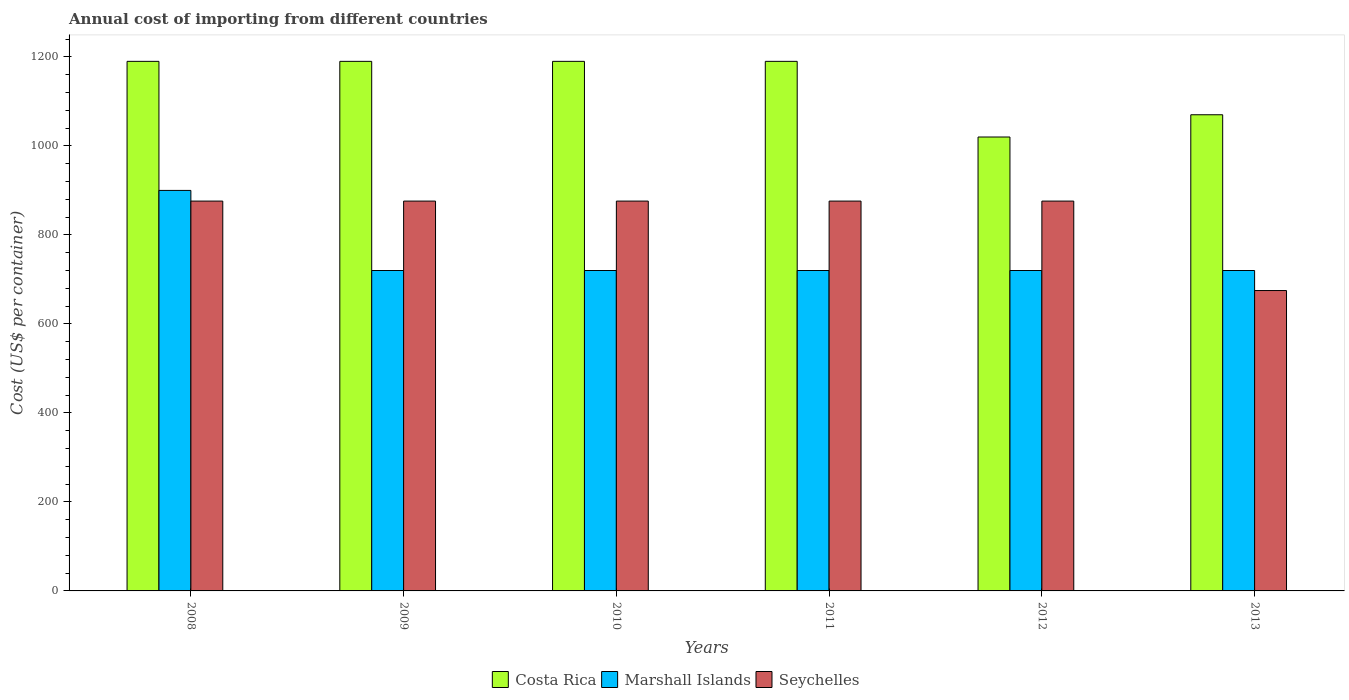How many bars are there on the 6th tick from the left?
Provide a short and direct response. 3. What is the total annual cost of importing in Seychelles in 2013?
Ensure brevity in your answer.  675. Across all years, what is the maximum total annual cost of importing in Marshall Islands?
Your response must be concise. 900. Across all years, what is the minimum total annual cost of importing in Costa Rica?
Provide a short and direct response. 1020. In which year was the total annual cost of importing in Costa Rica maximum?
Your response must be concise. 2008. In which year was the total annual cost of importing in Seychelles minimum?
Ensure brevity in your answer.  2013. What is the total total annual cost of importing in Marshall Islands in the graph?
Provide a short and direct response. 4500. What is the difference between the total annual cost of importing in Seychelles in 2008 and that in 2011?
Offer a very short reply. 0. What is the difference between the total annual cost of importing in Seychelles in 2009 and the total annual cost of importing in Marshall Islands in 2013?
Keep it short and to the point. 156. What is the average total annual cost of importing in Seychelles per year?
Your answer should be very brief. 842.5. In the year 2008, what is the difference between the total annual cost of importing in Seychelles and total annual cost of importing in Marshall Islands?
Keep it short and to the point. -24. What is the ratio of the total annual cost of importing in Seychelles in 2009 to that in 2011?
Make the answer very short. 1. What is the difference between the highest and the second highest total annual cost of importing in Seychelles?
Offer a very short reply. 0. What is the difference between the highest and the lowest total annual cost of importing in Marshall Islands?
Ensure brevity in your answer.  180. In how many years, is the total annual cost of importing in Seychelles greater than the average total annual cost of importing in Seychelles taken over all years?
Keep it short and to the point. 5. What does the 1st bar from the left in 2011 represents?
Provide a succinct answer. Costa Rica. What does the 3rd bar from the right in 2008 represents?
Give a very brief answer. Costa Rica. How many bars are there?
Your response must be concise. 18. What is the difference between two consecutive major ticks on the Y-axis?
Your answer should be compact. 200. Does the graph contain any zero values?
Provide a short and direct response. No. Does the graph contain grids?
Give a very brief answer. No. How are the legend labels stacked?
Provide a succinct answer. Horizontal. What is the title of the graph?
Provide a short and direct response. Annual cost of importing from different countries. Does "Singapore" appear as one of the legend labels in the graph?
Your response must be concise. No. What is the label or title of the Y-axis?
Offer a terse response. Cost (US$ per container). What is the Cost (US$ per container) in Costa Rica in 2008?
Keep it short and to the point. 1190. What is the Cost (US$ per container) of Marshall Islands in 2008?
Make the answer very short. 900. What is the Cost (US$ per container) of Seychelles in 2008?
Your answer should be compact. 876. What is the Cost (US$ per container) of Costa Rica in 2009?
Offer a very short reply. 1190. What is the Cost (US$ per container) of Marshall Islands in 2009?
Your response must be concise. 720. What is the Cost (US$ per container) in Seychelles in 2009?
Keep it short and to the point. 876. What is the Cost (US$ per container) of Costa Rica in 2010?
Make the answer very short. 1190. What is the Cost (US$ per container) of Marshall Islands in 2010?
Provide a short and direct response. 720. What is the Cost (US$ per container) of Seychelles in 2010?
Provide a short and direct response. 876. What is the Cost (US$ per container) of Costa Rica in 2011?
Keep it short and to the point. 1190. What is the Cost (US$ per container) in Marshall Islands in 2011?
Make the answer very short. 720. What is the Cost (US$ per container) in Seychelles in 2011?
Ensure brevity in your answer.  876. What is the Cost (US$ per container) in Costa Rica in 2012?
Ensure brevity in your answer.  1020. What is the Cost (US$ per container) of Marshall Islands in 2012?
Provide a succinct answer. 720. What is the Cost (US$ per container) in Seychelles in 2012?
Give a very brief answer. 876. What is the Cost (US$ per container) of Costa Rica in 2013?
Provide a short and direct response. 1070. What is the Cost (US$ per container) of Marshall Islands in 2013?
Ensure brevity in your answer.  720. What is the Cost (US$ per container) of Seychelles in 2013?
Offer a terse response. 675. Across all years, what is the maximum Cost (US$ per container) of Costa Rica?
Keep it short and to the point. 1190. Across all years, what is the maximum Cost (US$ per container) of Marshall Islands?
Offer a very short reply. 900. Across all years, what is the maximum Cost (US$ per container) of Seychelles?
Make the answer very short. 876. Across all years, what is the minimum Cost (US$ per container) of Costa Rica?
Your answer should be compact. 1020. Across all years, what is the minimum Cost (US$ per container) in Marshall Islands?
Offer a terse response. 720. Across all years, what is the minimum Cost (US$ per container) of Seychelles?
Your response must be concise. 675. What is the total Cost (US$ per container) in Costa Rica in the graph?
Offer a very short reply. 6850. What is the total Cost (US$ per container) in Marshall Islands in the graph?
Make the answer very short. 4500. What is the total Cost (US$ per container) in Seychelles in the graph?
Provide a succinct answer. 5055. What is the difference between the Cost (US$ per container) in Marshall Islands in 2008 and that in 2009?
Your response must be concise. 180. What is the difference between the Cost (US$ per container) in Costa Rica in 2008 and that in 2010?
Ensure brevity in your answer.  0. What is the difference between the Cost (US$ per container) in Marshall Islands in 2008 and that in 2010?
Your response must be concise. 180. What is the difference between the Cost (US$ per container) of Seychelles in 2008 and that in 2010?
Ensure brevity in your answer.  0. What is the difference between the Cost (US$ per container) of Marshall Islands in 2008 and that in 2011?
Provide a short and direct response. 180. What is the difference between the Cost (US$ per container) in Costa Rica in 2008 and that in 2012?
Ensure brevity in your answer.  170. What is the difference between the Cost (US$ per container) of Marshall Islands in 2008 and that in 2012?
Give a very brief answer. 180. What is the difference between the Cost (US$ per container) of Seychelles in 2008 and that in 2012?
Make the answer very short. 0. What is the difference between the Cost (US$ per container) of Costa Rica in 2008 and that in 2013?
Give a very brief answer. 120. What is the difference between the Cost (US$ per container) of Marshall Islands in 2008 and that in 2013?
Provide a short and direct response. 180. What is the difference between the Cost (US$ per container) in Seychelles in 2008 and that in 2013?
Offer a terse response. 201. What is the difference between the Cost (US$ per container) of Costa Rica in 2009 and that in 2010?
Keep it short and to the point. 0. What is the difference between the Cost (US$ per container) of Marshall Islands in 2009 and that in 2010?
Your response must be concise. 0. What is the difference between the Cost (US$ per container) in Seychelles in 2009 and that in 2010?
Offer a terse response. 0. What is the difference between the Cost (US$ per container) of Costa Rica in 2009 and that in 2011?
Make the answer very short. 0. What is the difference between the Cost (US$ per container) of Marshall Islands in 2009 and that in 2011?
Make the answer very short. 0. What is the difference between the Cost (US$ per container) of Seychelles in 2009 and that in 2011?
Keep it short and to the point. 0. What is the difference between the Cost (US$ per container) of Costa Rica in 2009 and that in 2012?
Keep it short and to the point. 170. What is the difference between the Cost (US$ per container) of Costa Rica in 2009 and that in 2013?
Make the answer very short. 120. What is the difference between the Cost (US$ per container) of Seychelles in 2009 and that in 2013?
Offer a terse response. 201. What is the difference between the Cost (US$ per container) of Costa Rica in 2010 and that in 2012?
Give a very brief answer. 170. What is the difference between the Cost (US$ per container) of Marshall Islands in 2010 and that in 2012?
Provide a short and direct response. 0. What is the difference between the Cost (US$ per container) in Seychelles in 2010 and that in 2012?
Offer a very short reply. 0. What is the difference between the Cost (US$ per container) of Costa Rica in 2010 and that in 2013?
Ensure brevity in your answer.  120. What is the difference between the Cost (US$ per container) of Marshall Islands in 2010 and that in 2013?
Ensure brevity in your answer.  0. What is the difference between the Cost (US$ per container) in Seychelles in 2010 and that in 2013?
Ensure brevity in your answer.  201. What is the difference between the Cost (US$ per container) in Costa Rica in 2011 and that in 2012?
Provide a short and direct response. 170. What is the difference between the Cost (US$ per container) in Seychelles in 2011 and that in 2012?
Offer a very short reply. 0. What is the difference between the Cost (US$ per container) of Costa Rica in 2011 and that in 2013?
Give a very brief answer. 120. What is the difference between the Cost (US$ per container) of Marshall Islands in 2011 and that in 2013?
Your answer should be compact. 0. What is the difference between the Cost (US$ per container) of Seychelles in 2011 and that in 2013?
Your answer should be compact. 201. What is the difference between the Cost (US$ per container) of Costa Rica in 2012 and that in 2013?
Offer a very short reply. -50. What is the difference between the Cost (US$ per container) of Marshall Islands in 2012 and that in 2013?
Your answer should be compact. 0. What is the difference between the Cost (US$ per container) of Seychelles in 2012 and that in 2013?
Your answer should be very brief. 201. What is the difference between the Cost (US$ per container) of Costa Rica in 2008 and the Cost (US$ per container) of Marshall Islands in 2009?
Your answer should be very brief. 470. What is the difference between the Cost (US$ per container) in Costa Rica in 2008 and the Cost (US$ per container) in Seychelles in 2009?
Offer a terse response. 314. What is the difference between the Cost (US$ per container) of Costa Rica in 2008 and the Cost (US$ per container) of Marshall Islands in 2010?
Your answer should be very brief. 470. What is the difference between the Cost (US$ per container) in Costa Rica in 2008 and the Cost (US$ per container) in Seychelles in 2010?
Make the answer very short. 314. What is the difference between the Cost (US$ per container) of Costa Rica in 2008 and the Cost (US$ per container) of Marshall Islands in 2011?
Give a very brief answer. 470. What is the difference between the Cost (US$ per container) of Costa Rica in 2008 and the Cost (US$ per container) of Seychelles in 2011?
Offer a terse response. 314. What is the difference between the Cost (US$ per container) in Costa Rica in 2008 and the Cost (US$ per container) in Marshall Islands in 2012?
Provide a succinct answer. 470. What is the difference between the Cost (US$ per container) of Costa Rica in 2008 and the Cost (US$ per container) of Seychelles in 2012?
Make the answer very short. 314. What is the difference between the Cost (US$ per container) of Costa Rica in 2008 and the Cost (US$ per container) of Marshall Islands in 2013?
Provide a succinct answer. 470. What is the difference between the Cost (US$ per container) of Costa Rica in 2008 and the Cost (US$ per container) of Seychelles in 2013?
Your answer should be compact. 515. What is the difference between the Cost (US$ per container) in Marshall Islands in 2008 and the Cost (US$ per container) in Seychelles in 2013?
Ensure brevity in your answer.  225. What is the difference between the Cost (US$ per container) in Costa Rica in 2009 and the Cost (US$ per container) in Marshall Islands in 2010?
Your response must be concise. 470. What is the difference between the Cost (US$ per container) in Costa Rica in 2009 and the Cost (US$ per container) in Seychelles in 2010?
Your answer should be compact. 314. What is the difference between the Cost (US$ per container) in Marshall Islands in 2009 and the Cost (US$ per container) in Seychelles in 2010?
Your answer should be very brief. -156. What is the difference between the Cost (US$ per container) in Costa Rica in 2009 and the Cost (US$ per container) in Marshall Islands in 2011?
Give a very brief answer. 470. What is the difference between the Cost (US$ per container) in Costa Rica in 2009 and the Cost (US$ per container) in Seychelles in 2011?
Your response must be concise. 314. What is the difference between the Cost (US$ per container) of Marshall Islands in 2009 and the Cost (US$ per container) of Seychelles in 2011?
Offer a very short reply. -156. What is the difference between the Cost (US$ per container) in Costa Rica in 2009 and the Cost (US$ per container) in Marshall Islands in 2012?
Make the answer very short. 470. What is the difference between the Cost (US$ per container) in Costa Rica in 2009 and the Cost (US$ per container) in Seychelles in 2012?
Your response must be concise. 314. What is the difference between the Cost (US$ per container) of Marshall Islands in 2009 and the Cost (US$ per container) of Seychelles in 2012?
Offer a terse response. -156. What is the difference between the Cost (US$ per container) in Costa Rica in 2009 and the Cost (US$ per container) in Marshall Islands in 2013?
Provide a short and direct response. 470. What is the difference between the Cost (US$ per container) of Costa Rica in 2009 and the Cost (US$ per container) of Seychelles in 2013?
Provide a succinct answer. 515. What is the difference between the Cost (US$ per container) of Marshall Islands in 2009 and the Cost (US$ per container) of Seychelles in 2013?
Ensure brevity in your answer.  45. What is the difference between the Cost (US$ per container) of Costa Rica in 2010 and the Cost (US$ per container) of Marshall Islands in 2011?
Ensure brevity in your answer.  470. What is the difference between the Cost (US$ per container) of Costa Rica in 2010 and the Cost (US$ per container) of Seychelles in 2011?
Provide a short and direct response. 314. What is the difference between the Cost (US$ per container) in Marshall Islands in 2010 and the Cost (US$ per container) in Seychelles in 2011?
Offer a very short reply. -156. What is the difference between the Cost (US$ per container) in Costa Rica in 2010 and the Cost (US$ per container) in Marshall Islands in 2012?
Your answer should be compact. 470. What is the difference between the Cost (US$ per container) in Costa Rica in 2010 and the Cost (US$ per container) in Seychelles in 2012?
Offer a terse response. 314. What is the difference between the Cost (US$ per container) of Marshall Islands in 2010 and the Cost (US$ per container) of Seychelles in 2012?
Make the answer very short. -156. What is the difference between the Cost (US$ per container) of Costa Rica in 2010 and the Cost (US$ per container) of Marshall Islands in 2013?
Provide a succinct answer. 470. What is the difference between the Cost (US$ per container) of Costa Rica in 2010 and the Cost (US$ per container) of Seychelles in 2013?
Give a very brief answer. 515. What is the difference between the Cost (US$ per container) of Costa Rica in 2011 and the Cost (US$ per container) of Marshall Islands in 2012?
Offer a terse response. 470. What is the difference between the Cost (US$ per container) of Costa Rica in 2011 and the Cost (US$ per container) of Seychelles in 2012?
Your answer should be compact. 314. What is the difference between the Cost (US$ per container) in Marshall Islands in 2011 and the Cost (US$ per container) in Seychelles in 2012?
Your answer should be very brief. -156. What is the difference between the Cost (US$ per container) of Costa Rica in 2011 and the Cost (US$ per container) of Marshall Islands in 2013?
Your answer should be very brief. 470. What is the difference between the Cost (US$ per container) of Costa Rica in 2011 and the Cost (US$ per container) of Seychelles in 2013?
Offer a very short reply. 515. What is the difference between the Cost (US$ per container) in Marshall Islands in 2011 and the Cost (US$ per container) in Seychelles in 2013?
Your answer should be compact. 45. What is the difference between the Cost (US$ per container) in Costa Rica in 2012 and the Cost (US$ per container) in Marshall Islands in 2013?
Your answer should be compact. 300. What is the difference between the Cost (US$ per container) in Costa Rica in 2012 and the Cost (US$ per container) in Seychelles in 2013?
Offer a very short reply. 345. What is the average Cost (US$ per container) of Costa Rica per year?
Give a very brief answer. 1141.67. What is the average Cost (US$ per container) of Marshall Islands per year?
Give a very brief answer. 750. What is the average Cost (US$ per container) of Seychelles per year?
Keep it short and to the point. 842.5. In the year 2008, what is the difference between the Cost (US$ per container) of Costa Rica and Cost (US$ per container) of Marshall Islands?
Provide a succinct answer. 290. In the year 2008, what is the difference between the Cost (US$ per container) in Costa Rica and Cost (US$ per container) in Seychelles?
Provide a short and direct response. 314. In the year 2009, what is the difference between the Cost (US$ per container) of Costa Rica and Cost (US$ per container) of Marshall Islands?
Keep it short and to the point. 470. In the year 2009, what is the difference between the Cost (US$ per container) in Costa Rica and Cost (US$ per container) in Seychelles?
Ensure brevity in your answer.  314. In the year 2009, what is the difference between the Cost (US$ per container) of Marshall Islands and Cost (US$ per container) of Seychelles?
Keep it short and to the point. -156. In the year 2010, what is the difference between the Cost (US$ per container) of Costa Rica and Cost (US$ per container) of Marshall Islands?
Provide a succinct answer. 470. In the year 2010, what is the difference between the Cost (US$ per container) of Costa Rica and Cost (US$ per container) of Seychelles?
Provide a short and direct response. 314. In the year 2010, what is the difference between the Cost (US$ per container) of Marshall Islands and Cost (US$ per container) of Seychelles?
Your response must be concise. -156. In the year 2011, what is the difference between the Cost (US$ per container) in Costa Rica and Cost (US$ per container) in Marshall Islands?
Your answer should be compact. 470. In the year 2011, what is the difference between the Cost (US$ per container) of Costa Rica and Cost (US$ per container) of Seychelles?
Make the answer very short. 314. In the year 2011, what is the difference between the Cost (US$ per container) of Marshall Islands and Cost (US$ per container) of Seychelles?
Make the answer very short. -156. In the year 2012, what is the difference between the Cost (US$ per container) in Costa Rica and Cost (US$ per container) in Marshall Islands?
Ensure brevity in your answer.  300. In the year 2012, what is the difference between the Cost (US$ per container) of Costa Rica and Cost (US$ per container) of Seychelles?
Your response must be concise. 144. In the year 2012, what is the difference between the Cost (US$ per container) of Marshall Islands and Cost (US$ per container) of Seychelles?
Your response must be concise. -156. In the year 2013, what is the difference between the Cost (US$ per container) of Costa Rica and Cost (US$ per container) of Marshall Islands?
Your response must be concise. 350. In the year 2013, what is the difference between the Cost (US$ per container) in Costa Rica and Cost (US$ per container) in Seychelles?
Provide a short and direct response. 395. In the year 2013, what is the difference between the Cost (US$ per container) in Marshall Islands and Cost (US$ per container) in Seychelles?
Your response must be concise. 45. What is the ratio of the Cost (US$ per container) of Costa Rica in 2008 to that in 2009?
Make the answer very short. 1. What is the ratio of the Cost (US$ per container) in Marshall Islands in 2008 to that in 2009?
Give a very brief answer. 1.25. What is the ratio of the Cost (US$ per container) in Seychelles in 2008 to that in 2010?
Offer a very short reply. 1. What is the ratio of the Cost (US$ per container) of Costa Rica in 2008 to that in 2011?
Offer a very short reply. 1. What is the ratio of the Cost (US$ per container) in Marshall Islands in 2008 to that in 2011?
Make the answer very short. 1.25. What is the ratio of the Cost (US$ per container) of Costa Rica in 2008 to that in 2012?
Provide a succinct answer. 1.17. What is the ratio of the Cost (US$ per container) in Seychelles in 2008 to that in 2012?
Your response must be concise. 1. What is the ratio of the Cost (US$ per container) of Costa Rica in 2008 to that in 2013?
Offer a very short reply. 1.11. What is the ratio of the Cost (US$ per container) of Marshall Islands in 2008 to that in 2013?
Give a very brief answer. 1.25. What is the ratio of the Cost (US$ per container) of Seychelles in 2008 to that in 2013?
Offer a terse response. 1.3. What is the ratio of the Cost (US$ per container) in Costa Rica in 2009 to that in 2010?
Your answer should be compact. 1. What is the ratio of the Cost (US$ per container) in Seychelles in 2009 to that in 2011?
Your answer should be very brief. 1. What is the ratio of the Cost (US$ per container) of Costa Rica in 2009 to that in 2012?
Provide a short and direct response. 1.17. What is the ratio of the Cost (US$ per container) of Seychelles in 2009 to that in 2012?
Ensure brevity in your answer.  1. What is the ratio of the Cost (US$ per container) of Costa Rica in 2009 to that in 2013?
Give a very brief answer. 1.11. What is the ratio of the Cost (US$ per container) of Marshall Islands in 2009 to that in 2013?
Ensure brevity in your answer.  1. What is the ratio of the Cost (US$ per container) of Seychelles in 2009 to that in 2013?
Make the answer very short. 1.3. What is the ratio of the Cost (US$ per container) of Costa Rica in 2010 to that in 2011?
Your answer should be compact. 1. What is the ratio of the Cost (US$ per container) of Costa Rica in 2010 to that in 2012?
Keep it short and to the point. 1.17. What is the ratio of the Cost (US$ per container) of Seychelles in 2010 to that in 2012?
Provide a short and direct response. 1. What is the ratio of the Cost (US$ per container) of Costa Rica in 2010 to that in 2013?
Provide a succinct answer. 1.11. What is the ratio of the Cost (US$ per container) in Seychelles in 2010 to that in 2013?
Provide a succinct answer. 1.3. What is the ratio of the Cost (US$ per container) of Costa Rica in 2011 to that in 2012?
Give a very brief answer. 1.17. What is the ratio of the Cost (US$ per container) in Marshall Islands in 2011 to that in 2012?
Your answer should be compact. 1. What is the ratio of the Cost (US$ per container) in Seychelles in 2011 to that in 2012?
Ensure brevity in your answer.  1. What is the ratio of the Cost (US$ per container) in Costa Rica in 2011 to that in 2013?
Your answer should be very brief. 1.11. What is the ratio of the Cost (US$ per container) in Seychelles in 2011 to that in 2013?
Keep it short and to the point. 1.3. What is the ratio of the Cost (US$ per container) in Costa Rica in 2012 to that in 2013?
Give a very brief answer. 0.95. What is the ratio of the Cost (US$ per container) of Marshall Islands in 2012 to that in 2013?
Make the answer very short. 1. What is the ratio of the Cost (US$ per container) of Seychelles in 2012 to that in 2013?
Keep it short and to the point. 1.3. What is the difference between the highest and the second highest Cost (US$ per container) in Costa Rica?
Your response must be concise. 0. What is the difference between the highest and the second highest Cost (US$ per container) of Marshall Islands?
Your response must be concise. 180. What is the difference between the highest and the lowest Cost (US$ per container) of Costa Rica?
Ensure brevity in your answer.  170. What is the difference between the highest and the lowest Cost (US$ per container) in Marshall Islands?
Make the answer very short. 180. What is the difference between the highest and the lowest Cost (US$ per container) of Seychelles?
Offer a terse response. 201. 